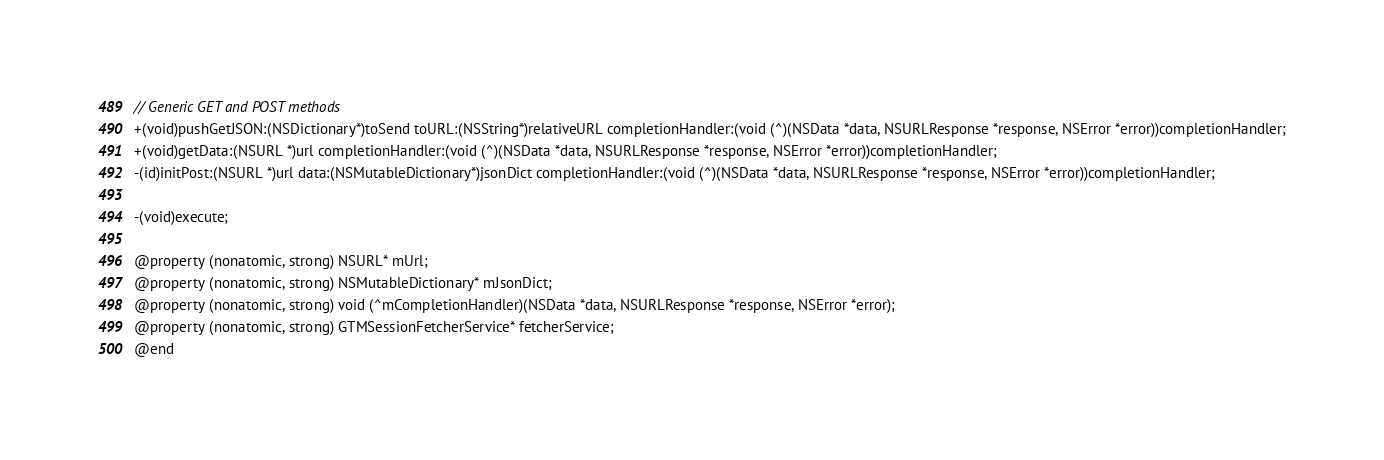<code> <loc_0><loc_0><loc_500><loc_500><_C_>
// Generic GET and POST methods
+(void)pushGetJSON:(NSDictionary*)toSend toURL:(NSString*)relativeURL completionHandler:(void (^)(NSData *data, NSURLResponse *response, NSError *error))completionHandler;
+(void)getData:(NSURL *)url completionHandler:(void (^)(NSData *data, NSURLResponse *response, NSError *error))completionHandler;
-(id)initPost:(NSURL *)url data:(NSMutableDictionary*)jsonDict completionHandler:(void (^)(NSData *data, NSURLResponse *response, NSError *error))completionHandler;

-(void)execute;

@property (nonatomic, strong) NSURL* mUrl;
@property (nonatomic, strong) NSMutableDictionary* mJsonDict;
@property (nonatomic, strong) void (^mCompletionHandler)(NSData *data, NSURLResponse *response, NSError *error);
@property (nonatomic, strong) GTMSessionFetcherService* fetcherService;
@end
</code> 